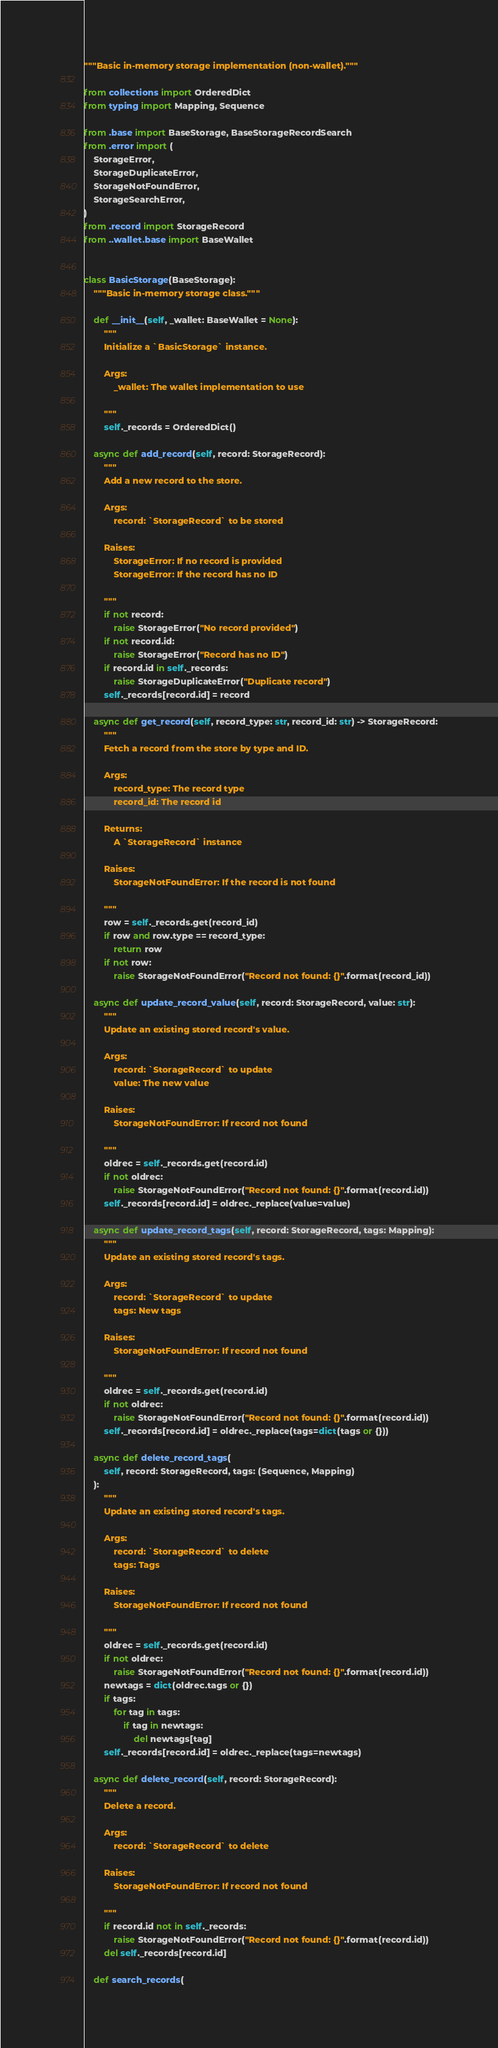Convert code to text. <code><loc_0><loc_0><loc_500><loc_500><_Python_>"""Basic in-memory storage implementation (non-wallet)."""

from collections import OrderedDict
from typing import Mapping, Sequence

from .base import BaseStorage, BaseStorageRecordSearch
from .error import (
    StorageError,
    StorageDuplicateError,
    StorageNotFoundError,
    StorageSearchError,
)
from .record import StorageRecord
from ..wallet.base import BaseWallet


class BasicStorage(BaseStorage):
    """Basic in-memory storage class."""

    def __init__(self, _wallet: BaseWallet = None):
        """
        Initialize a `BasicStorage` instance.

        Args:
            _wallet: The wallet implementation to use

        """
        self._records = OrderedDict()

    async def add_record(self, record: StorageRecord):
        """
        Add a new record to the store.

        Args:
            record: `StorageRecord` to be stored

        Raises:
            StorageError: If no record is provided
            StorageError: If the record has no ID

        """
        if not record:
            raise StorageError("No record provided")
        if not record.id:
            raise StorageError("Record has no ID")
        if record.id in self._records:
            raise StorageDuplicateError("Duplicate record")
        self._records[record.id] = record

    async def get_record(self, record_type: str, record_id: str) -> StorageRecord:
        """
        Fetch a record from the store by type and ID.

        Args:
            record_type: The record type
            record_id: The record id

        Returns:
            A `StorageRecord` instance

        Raises:
            StorageNotFoundError: If the record is not found

        """
        row = self._records.get(record_id)
        if row and row.type == record_type:
            return row
        if not row:
            raise StorageNotFoundError("Record not found: {}".format(record_id))

    async def update_record_value(self, record: StorageRecord, value: str):
        """
        Update an existing stored record's value.

        Args:
            record: `StorageRecord` to update
            value: The new value

        Raises:
            StorageNotFoundError: If record not found

        """
        oldrec = self._records.get(record.id)
        if not oldrec:
            raise StorageNotFoundError("Record not found: {}".format(record.id))
        self._records[record.id] = oldrec._replace(value=value)

    async def update_record_tags(self, record: StorageRecord, tags: Mapping):
        """
        Update an existing stored record's tags.

        Args:
            record: `StorageRecord` to update
            tags: New tags

        Raises:
            StorageNotFoundError: If record not found

        """
        oldrec = self._records.get(record.id)
        if not oldrec:
            raise StorageNotFoundError("Record not found: {}".format(record.id))
        self._records[record.id] = oldrec._replace(tags=dict(tags or {}))

    async def delete_record_tags(
        self, record: StorageRecord, tags: (Sequence, Mapping)
    ):
        """
        Update an existing stored record's tags.

        Args:
            record: `StorageRecord` to delete
            tags: Tags

        Raises:
            StorageNotFoundError: If record not found

        """
        oldrec = self._records.get(record.id)
        if not oldrec:
            raise StorageNotFoundError("Record not found: {}".format(record.id))
        newtags = dict(oldrec.tags or {})
        if tags:
            for tag in tags:
                if tag in newtags:
                    del newtags[tag]
        self._records[record.id] = oldrec._replace(tags=newtags)

    async def delete_record(self, record: StorageRecord):
        """
        Delete a record.

        Args:
            record: `StorageRecord` to delete

        Raises:
            StorageNotFoundError: If record not found

        """
        if record.id not in self._records:
            raise StorageNotFoundError("Record not found: {}".format(record.id))
        del self._records[record.id]

    def search_records(</code> 